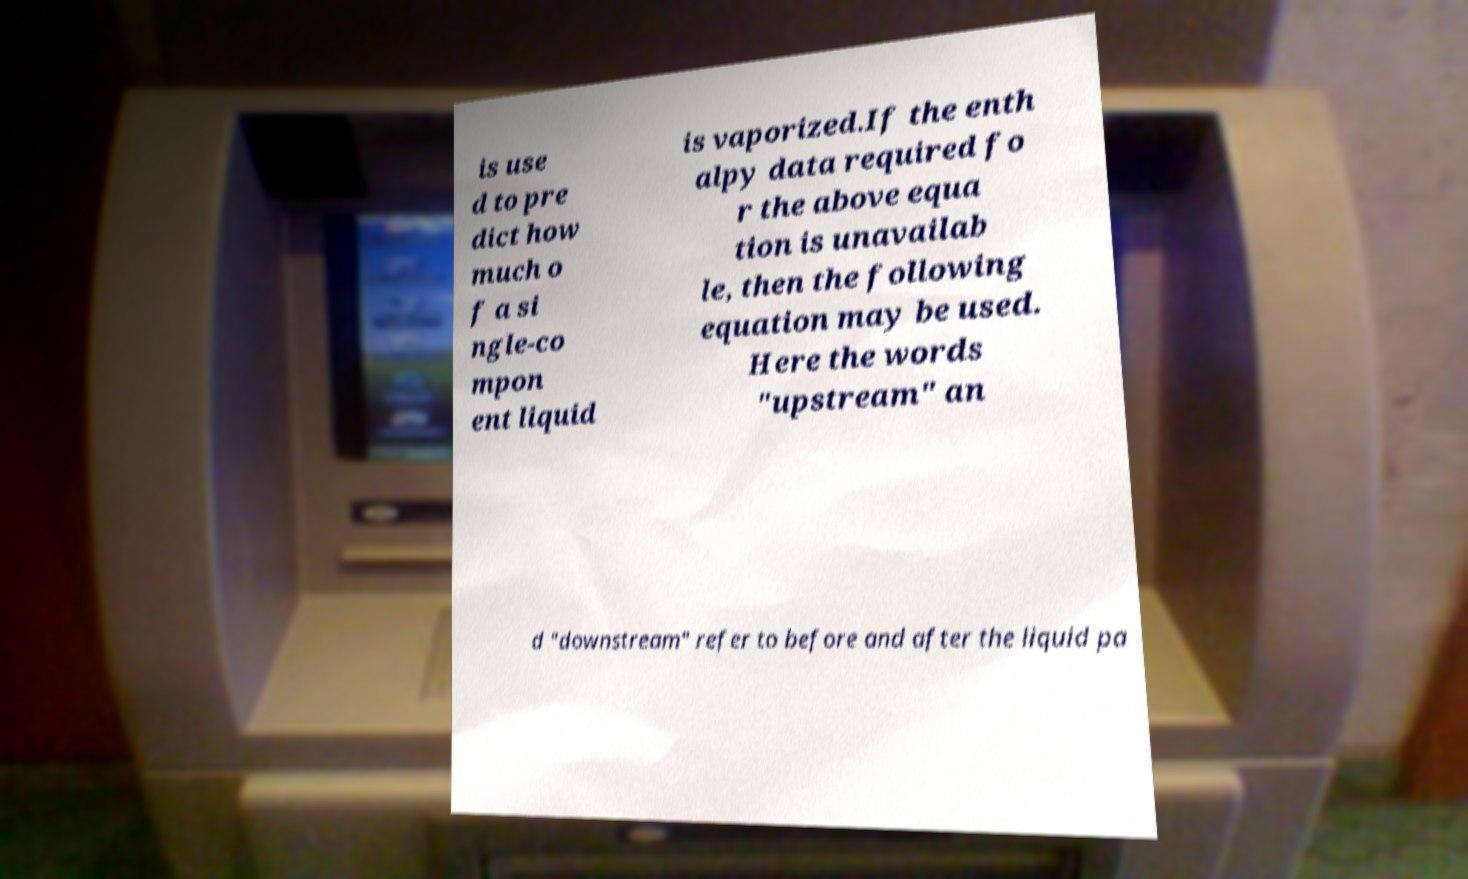Please identify and transcribe the text found in this image. is use d to pre dict how much o f a si ngle-co mpon ent liquid is vaporized.If the enth alpy data required fo r the above equa tion is unavailab le, then the following equation may be used. Here the words "upstream" an d "downstream" refer to before and after the liquid pa 